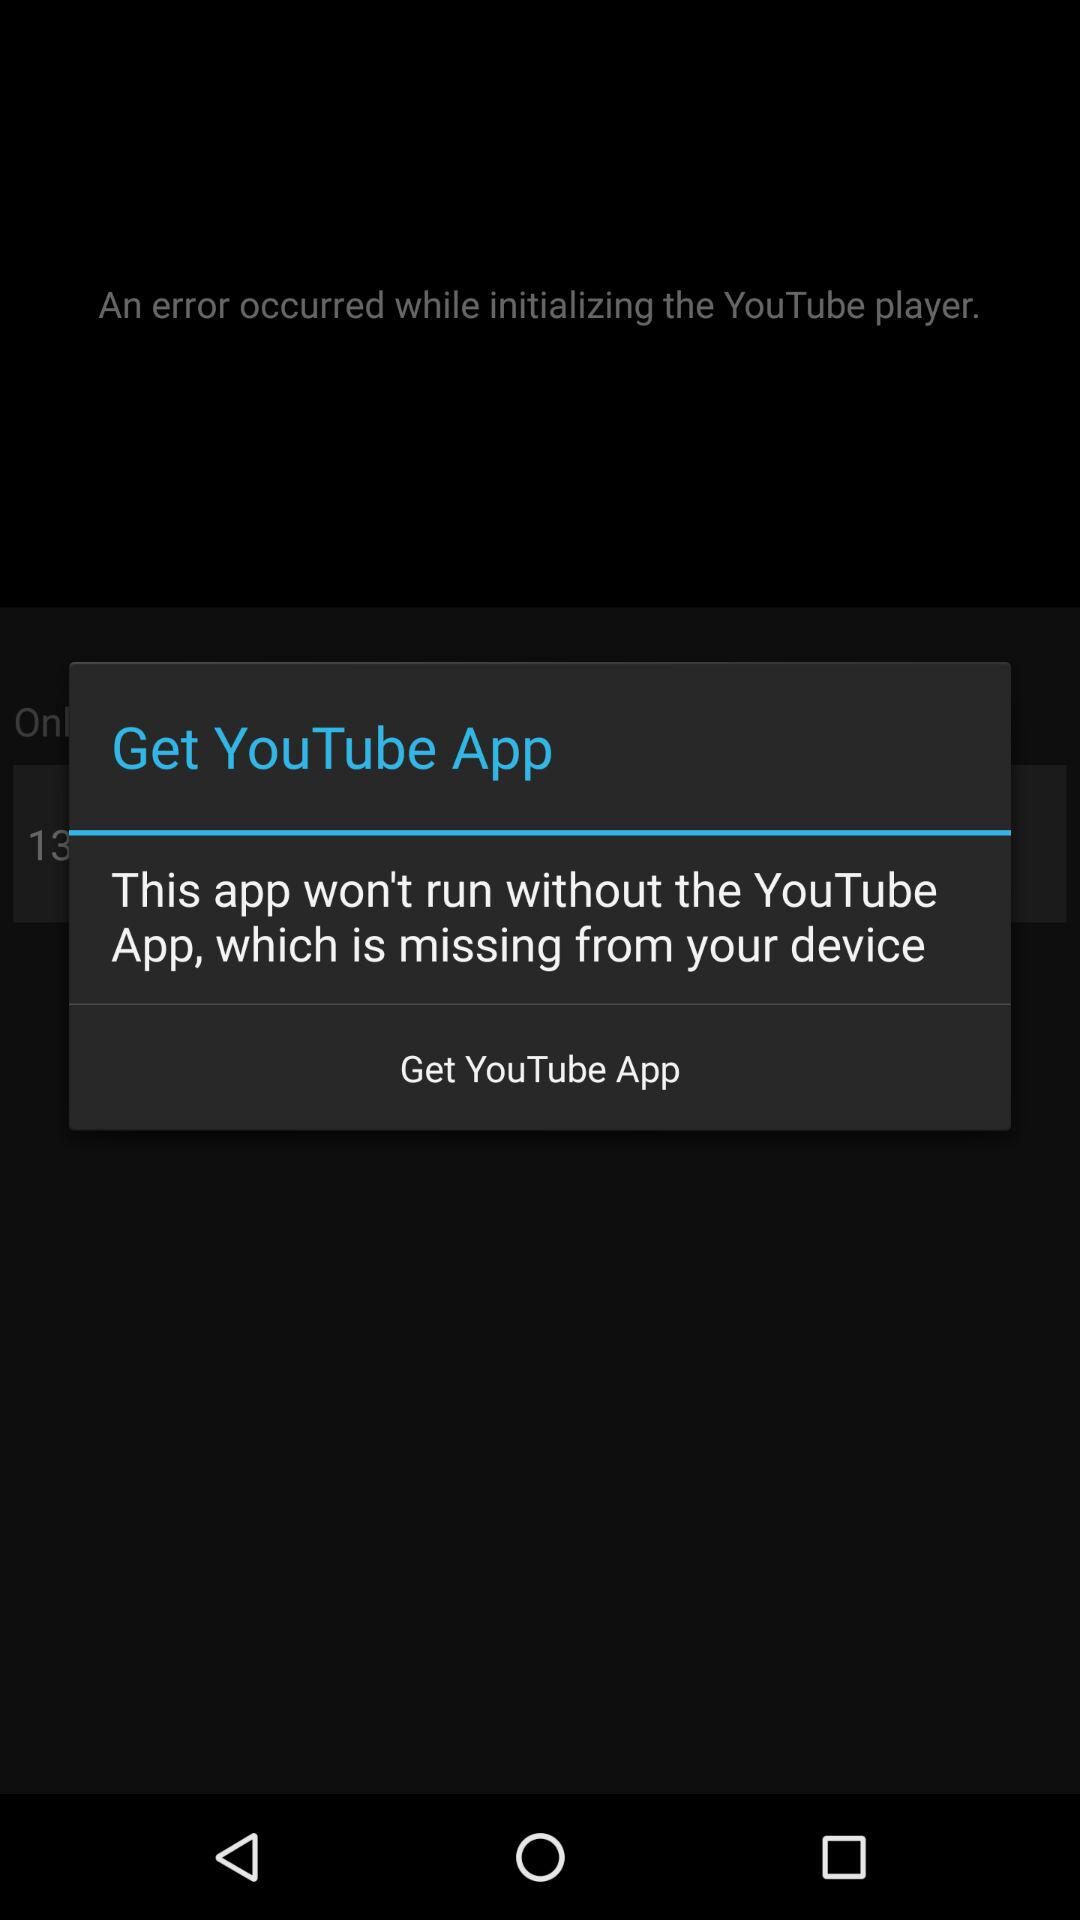What is the application name? The application name is "YouTube". 